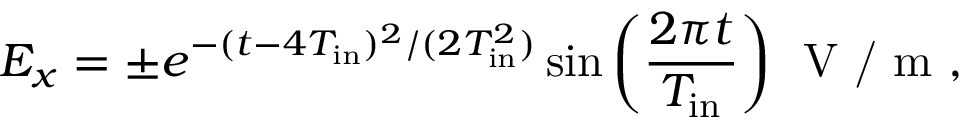Convert formula to latex. <formula><loc_0><loc_0><loc_500><loc_500>E _ { x } = \pm e ^ { - ( t - 4 T _ { i n } ) ^ { 2 } / ( 2 T _ { i n } ^ { 2 } ) } \sin { \left ( \frac { 2 \pi t } { T _ { i n } } \right ) } V / m ,</formula> 